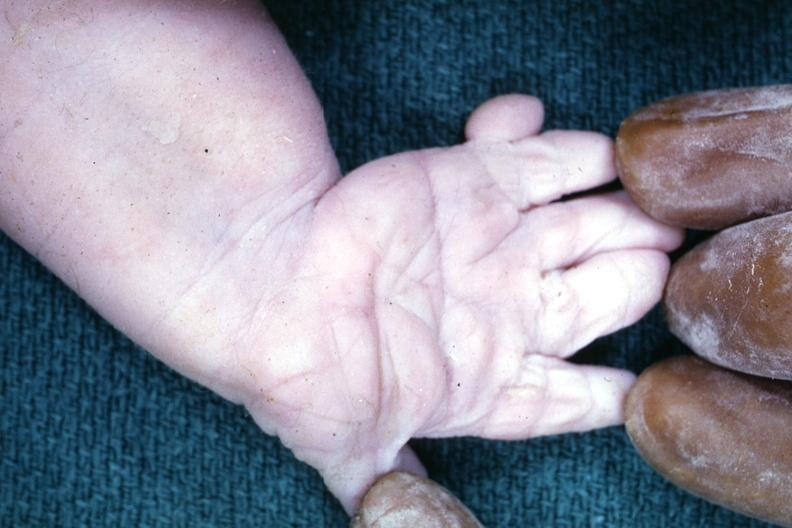s myocardial infarct present?
Answer the question using a single word or phrase. No 